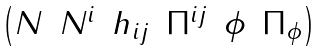<formula> <loc_0><loc_0><loc_500><loc_500>\begin{pmatrix} N & N ^ { i } & h _ { i j } & \Pi ^ { i j } & \phi & \Pi _ { \phi } \end{pmatrix}</formula> 